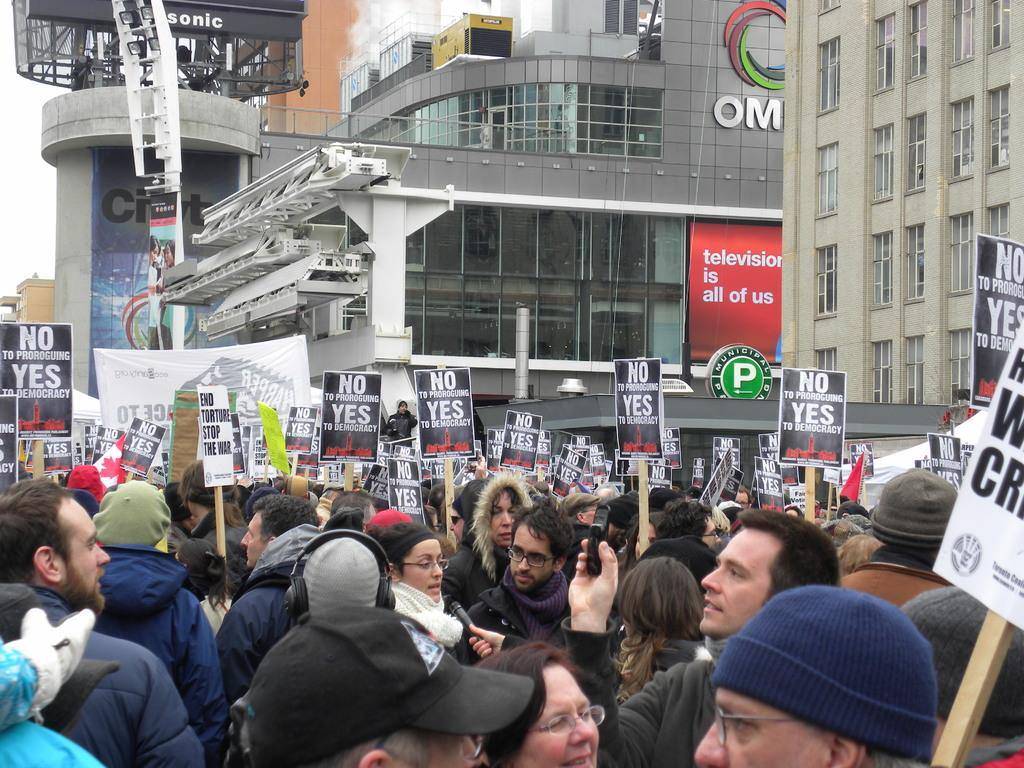What is happening in the center of the image? There are many people in the center of the image. What are the people holding in the image? The people are holding placards. What can be seen in the background of the image? There are buildings in the background of the image. How many dolls are sitting on the screw in the image? There are no dolls or screws present in the image. 